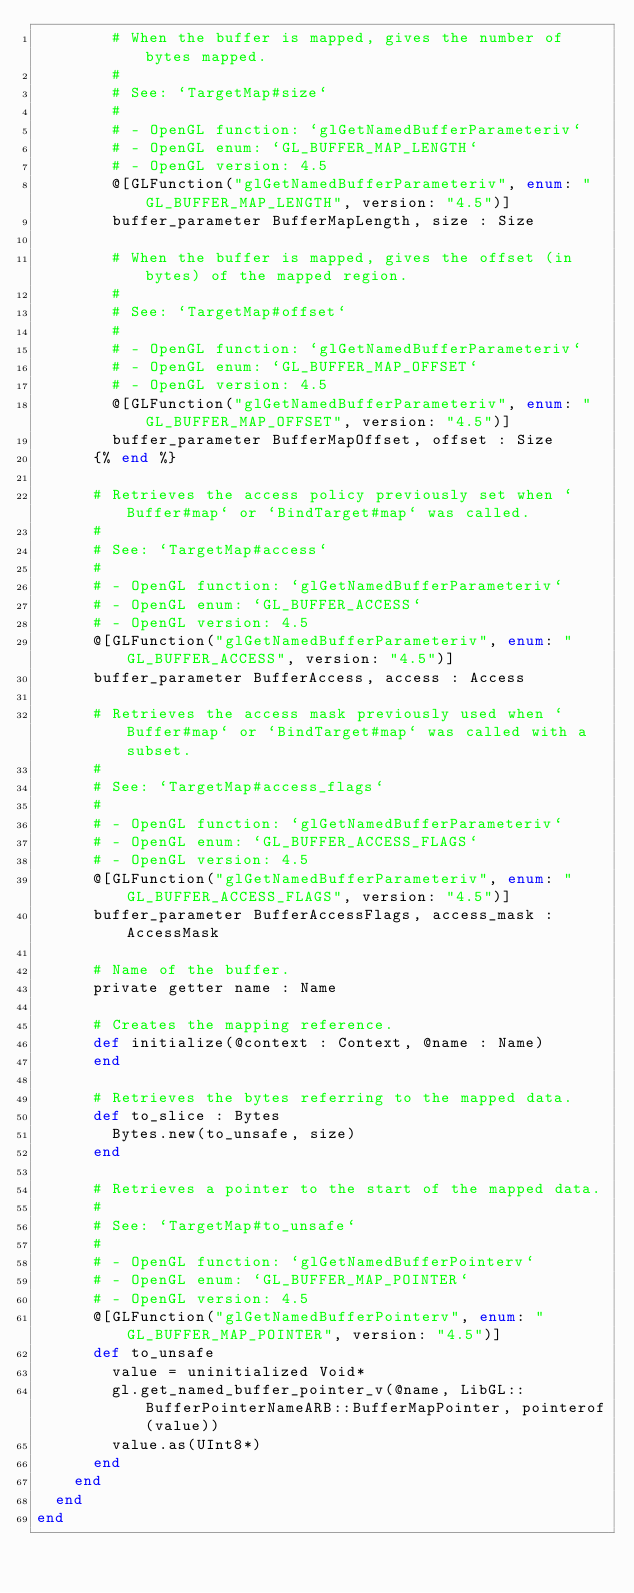<code> <loc_0><loc_0><loc_500><loc_500><_Crystal_>        # When the buffer is mapped, gives the number of bytes mapped.
        #
        # See: `TargetMap#size`
        #
        # - OpenGL function: `glGetNamedBufferParameteriv`
        # - OpenGL enum: `GL_BUFFER_MAP_LENGTH`
        # - OpenGL version: 4.5
        @[GLFunction("glGetNamedBufferParameteriv", enum: "GL_BUFFER_MAP_LENGTH", version: "4.5")]
        buffer_parameter BufferMapLength, size : Size

        # When the buffer is mapped, gives the offset (in bytes) of the mapped region.
        #
        # See: `TargetMap#offset`
        #
        # - OpenGL function: `glGetNamedBufferParameteriv`
        # - OpenGL enum: `GL_BUFFER_MAP_OFFSET`
        # - OpenGL version: 4.5
        @[GLFunction("glGetNamedBufferParameteriv", enum: "GL_BUFFER_MAP_OFFSET", version: "4.5")]
        buffer_parameter BufferMapOffset, offset : Size
      {% end %}

      # Retrieves the access policy previously set when `Buffer#map` or `BindTarget#map` was called.
      #
      # See: `TargetMap#access`
      #
      # - OpenGL function: `glGetNamedBufferParameteriv`
      # - OpenGL enum: `GL_BUFFER_ACCESS`
      # - OpenGL version: 4.5
      @[GLFunction("glGetNamedBufferParameteriv", enum: "GL_BUFFER_ACCESS", version: "4.5")]
      buffer_parameter BufferAccess, access : Access

      # Retrieves the access mask previously used when `Buffer#map` or `BindTarget#map` was called with a subset.
      #
      # See: `TargetMap#access_flags`
      #
      # - OpenGL function: `glGetNamedBufferParameteriv`
      # - OpenGL enum: `GL_BUFFER_ACCESS_FLAGS`
      # - OpenGL version: 4.5
      @[GLFunction("glGetNamedBufferParameteriv", enum: "GL_BUFFER_ACCESS_FLAGS", version: "4.5")]
      buffer_parameter BufferAccessFlags, access_mask : AccessMask

      # Name of the buffer.
      private getter name : Name

      # Creates the mapping reference.
      def initialize(@context : Context, @name : Name)
      end

      # Retrieves the bytes referring to the mapped data.
      def to_slice : Bytes
        Bytes.new(to_unsafe, size)
      end

      # Retrieves a pointer to the start of the mapped data.
      #
      # See: `TargetMap#to_unsafe`
      #
      # - OpenGL function: `glGetNamedBufferPointerv`
      # - OpenGL enum: `GL_BUFFER_MAP_POINTER`
      # - OpenGL version: 4.5
      @[GLFunction("glGetNamedBufferPointerv", enum: "GL_BUFFER_MAP_POINTER", version: "4.5")]
      def to_unsafe
        value = uninitialized Void*
        gl.get_named_buffer_pointer_v(@name, LibGL::BufferPointerNameARB::BufferMapPointer, pointerof(value))
        value.as(UInt8*)
      end
    end
  end
end
</code> 